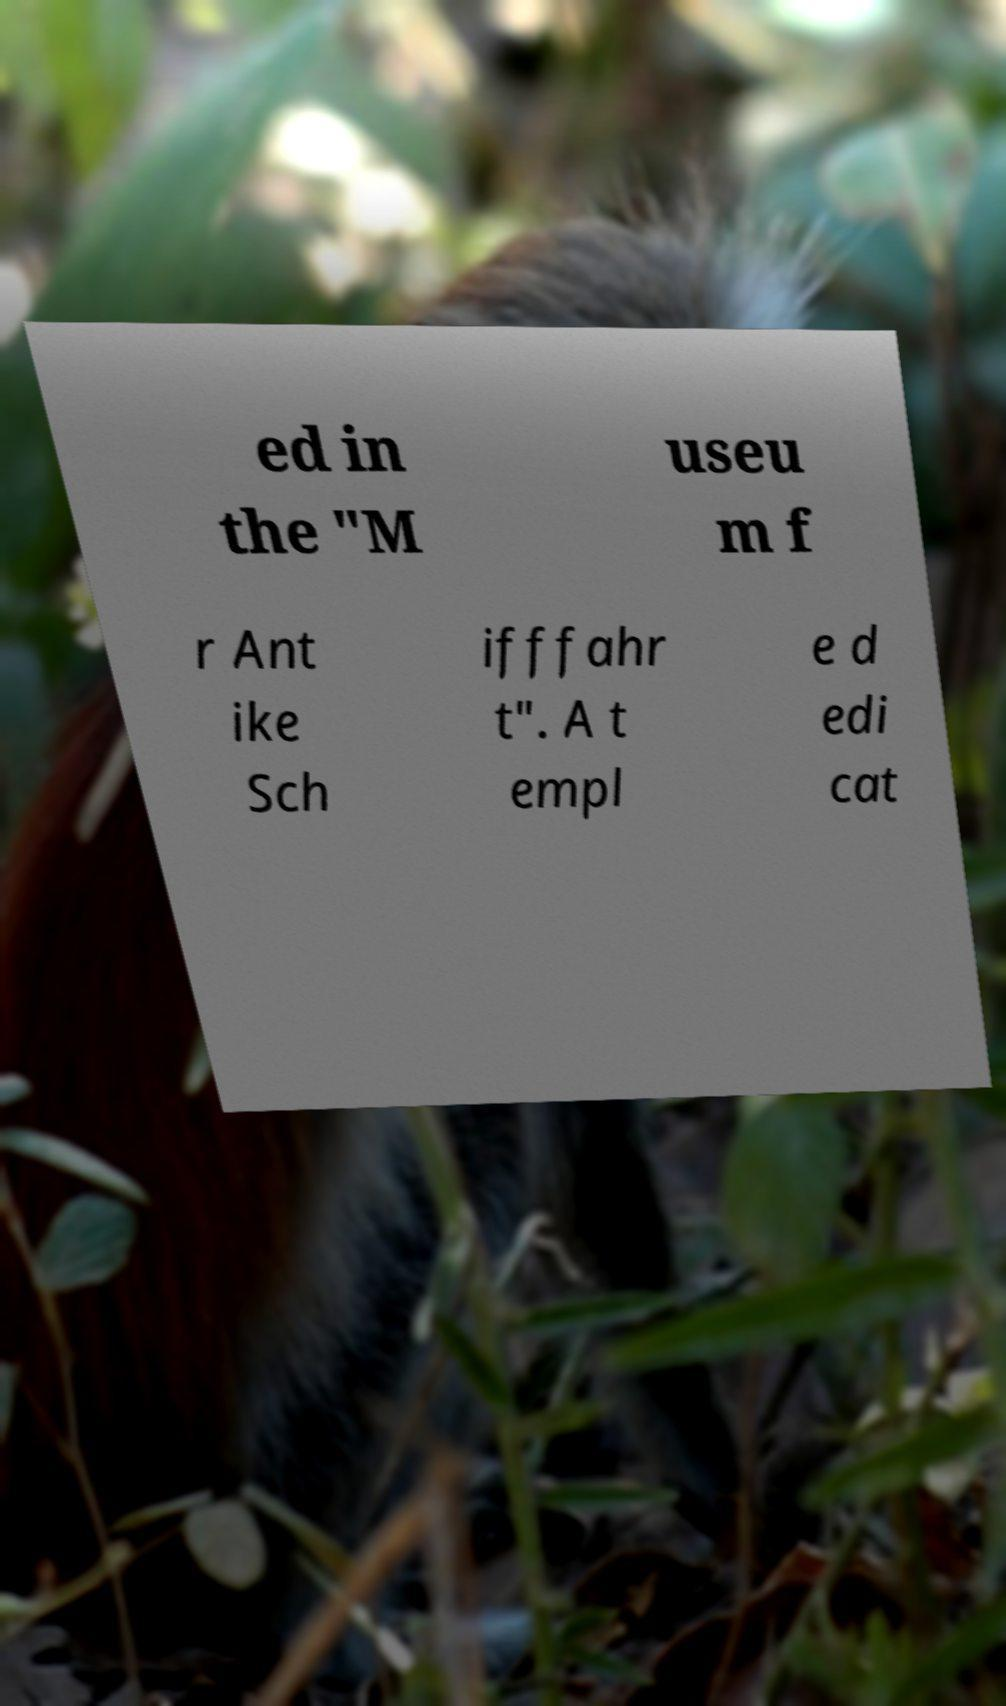Please read and relay the text visible in this image. What does it say? ed in the "M useu m f r Ant ike Sch ifffahr t". A t empl e d edi cat 